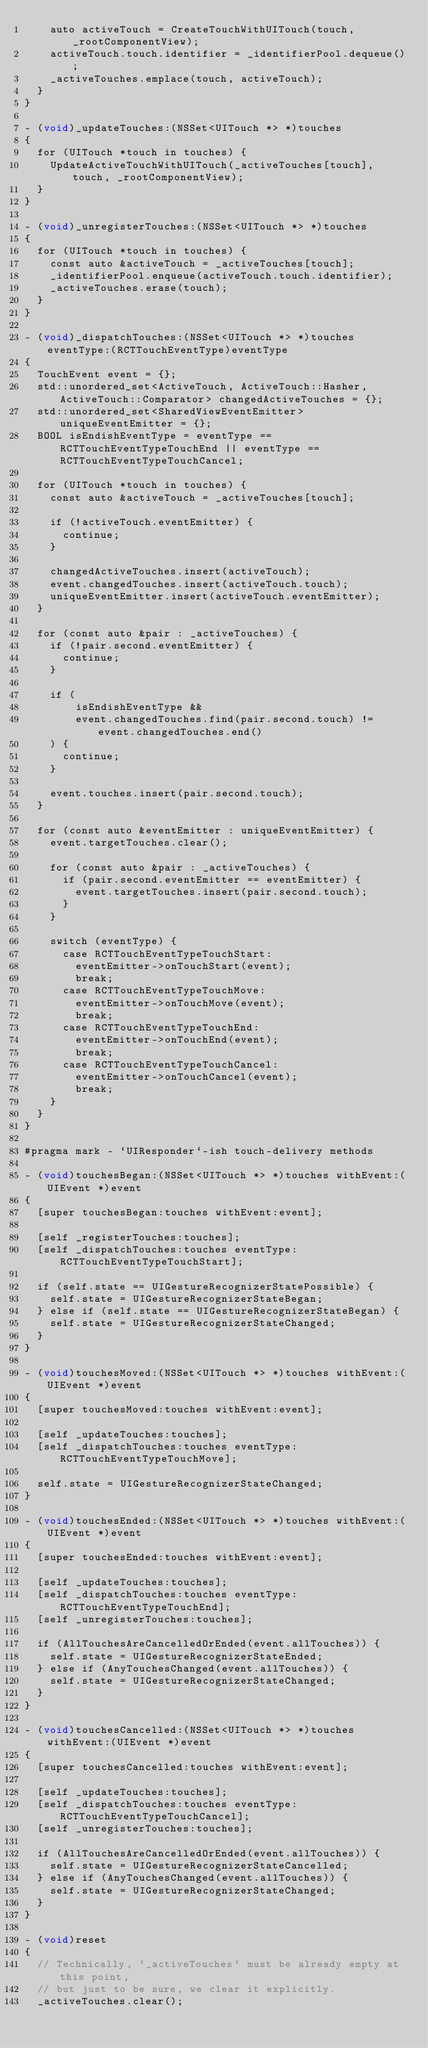<code> <loc_0><loc_0><loc_500><loc_500><_ObjectiveC_>    auto activeTouch = CreateTouchWithUITouch(touch, _rootComponentView);
    activeTouch.touch.identifier = _identifierPool.dequeue();
    _activeTouches.emplace(touch, activeTouch);
  }
}

- (void)_updateTouches:(NSSet<UITouch *> *)touches
{
  for (UITouch *touch in touches) {
    UpdateActiveTouchWithUITouch(_activeTouches[touch], touch, _rootComponentView);
  }
}

- (void)_unregisterTouches:(NSSet<UITouch *> *)touches
{
  for (UITouch *touch in touches) {
    const auto &activeTouch = _activeTouches[touch];
    _identifierPool.enqueue(activeTouch.touch.identifier);
    _activeTouches.erase(touch);
  }
}

- (void)_dispatchTouches:(NSSet<UITouch *> *)touches eventType:(RCTTouchEventType)eventType
{
  TouchEvent event = {};
  std::unordered_set<ActiveTouch, ActiveTouch::Hasher, ActiveTouch::Comparator> changedActiveTouches = {};
  std::unordered_set<SharedViewEventEmitter> uniqueEventEmitter = {};
  BOOL isEndishEventType = eventType == RCTTouchEventTypeTouchEnd || eventType == RCTTouchEventTypeTouchCancel;

  for (UITouch *touch in touches) {
    const auto &activeTouch = _activeTouches[touch];

    if (!activeTouch.eventEmitter) {
      continue;
    }

    changedActiveTouches.insert(activeTouch);
    event.changedTouches.insert(activeTouch.touch);
    uniqueEventEmitter.insert(activeTouch.eventEmitter);
  }

  for (const auto &pair : _activeTouches) {
    if (!pair.second.eventEmitter) {
      continue;
    }

    if (
        isEndishEventType &&
        event.changedTouches.find(pair.second.touch) != event.changedTouches.end()
    ) {
      continue;
    }

    event.touches.insert(pair.second.touch);
  }

  for (const auto &eventEmitter : uniqueEventEmitter) {
    event.targetTouches.clear();

    for (const auto &pair : _activeTouches) {
      if (pair.second.eventEmitter == eventEmitter) {
        event.targetTouches.insert(pair.second.touch);
      }
    }

    switch (eventType) {
      case RCTTouchEventTypeTouchStart:
        eventEmitter->onTouchStart(event);
        break;
      case RCTTouchEventTypeTouchMove:
        eventEmitter->onTouchMove(event);
        break;
      case RCTTouchEventTypeTouchEnd:
        eventEmitter->onTouchEnd(event);
        break;
      case RCTTouchEventTypeTouchCancel:
        eventEmitter->onTouchCancel(event);
        break;
    }
  }
}

#pragma mark - `UIResponder`-ish touch-delivery methods

- (void)touchesBegan:(NSSet<UITouch *> *)touches withEvent:(UIEvent *)event
{
  [super touchesBegan:touches withEvent:event];

  [self _registerTouches:touches];
  [self _dispatchTouches:touches eventType:RCTTouchEventTypeTouchStart];

  if (self.state == UIGestureRecognizerStatePossible) {
    self.state = UIGestureRecognizerStateBegan;
  } else if (self.state == UIGestureRecognizerStateBegan) {
    self.state = UIGestureRecognizerStateChanged;
  }
}

- (void)touchesMoved:(NSSet<UITouch *> *)touches withEvent:(UIEvent *)event
{
  [super touchesMoved:touches withEvent:event];

  [self _updateTouches:touches];
  [self _dispatchTouches:touches eventType:RCTTouchEventTypeTouchMove];

  self.state = UIGestureRecognizerStateChanged;
}

- (void)touchesEnded:(NSSet<UITouch *> *)touches withEvent:(UIEvent *)event
{
  [super touchesEnded:touches withEvent:event];

  [self _updateTouches:touches];
  [self _dispatchTouches:touches eventType:RCTTouchEventTypeTouchEnd];
  [self _unregisterTouches:touches];

  if (AllTouchesAreCancelledOrEnded(event.allTouches)) {
    self.state = UIGestureRecognizerStateEnded;
  } else if (AnyTouchesChanged(event.allTouches)) {
    self.state = UIGestureRecognizerStateChanged;
  }
}

- (void)touchesCancelled:(NSSet<UITouch *> *)touches withEvent:(UIEvent *)event
{
  [super touchesCancelled:touches withEvent:event];

  [self _updateTouches:touches];
  [self _dispatchTouches:touches eventType:RCTTouchEventTypeTouchCancel];
  [self _unregisterTouches:touches];

  if (AllTouchesAreCancelledOrEnded(event.allTouches)) {
    self.state = UIGestureRecognizerStateCancelled;
  } else if (AnyTouchesChanged(event.allTouches)) {
    self.state = UIGestureRecognizerStateChanged;
  }
}

- (void)reset
{
  // Technically, `_activeTouches` must be already empty at this point,
  // but just to be sure, we clear it explicitly.
  _activeTouches.clear();</code> 